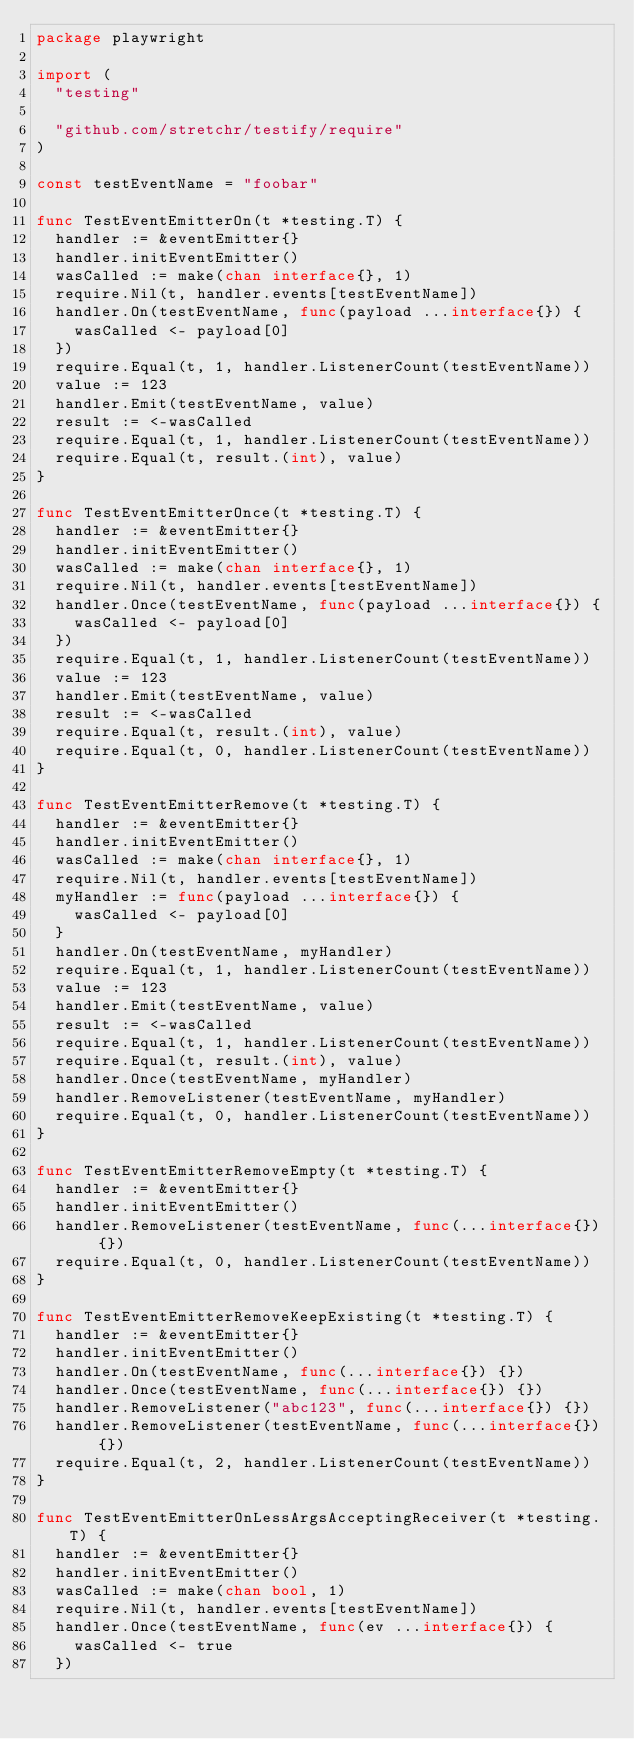<code> <loc_0><loc_0><loc_500><loc_500><_Go_>package playwright

import (
	"testing"

	"github.com/stretchr/testify/require"
)

const testEventName = "foobar"

func TestEventEmitterOn(t *testing.T) {
	handler := &eventEmitter{}
	handler.initEventEmitter()
	wasCalled := make(chan interface{}, 1)
	require.Nil(t, handler.events[testEventName])
	handler.On(testEventName, func(payload ...interface{}) {
		wasCalled <- payload[0]
	})
	require.Equal(t, 1, handler.ListenerCount(testEventName))
	value := 123
	handler.Emit(testEventName, value)
	result := <-wasCalled
	require.Equal(t, 1, handler.ListenerCount(testEventName))
	require.Equal(t, result.(int), value)
}

func TestEventEmitterOnce(t *testing.T) {
	handler := &eventEmitter{}
	handler.initEventEmitter()
	wasCalled := make(chan interface{}, 1)
	require.Nil(t, handler.events[testEventName])
	handler.Once(testEventName, func(payload ...interface{}) {
		wasCalled <- payload[0]
	})
	require.Equal(t, 1, handler.ListenerCount(testEventName))
	value := 123
	handler.Emit(testEventName, value)
	result := <-wasCalled
	require.Equal(t, result.(int), value)
	require.Equal(t, 0, handler.ListenerCount(testEventName))
}

func TestEventEmitterRemove(t *testing.T) {
	handler := &eventEmitter{}
	handler.initEventEmitter()
	wasCalled := make(chan interface{}, 1)
	require.Nil(t, handler.events[testEventName])
	myHandler := func(payload ...interface{}) {
		wasCalled <- payload[0]
	}
	handler.On(testEventName, myHandler)
	require.Equal(t, 1, handler.ListenerCount(testEventName))
	value := 123
	handler.Emit(testEventName, value)
	result := <-wasCalled
	require.Equal(t, 1, handler.ListenerCount(testEventName))
	require.Equal(t, result.(int), value)
	handler.Once(testEventName, myHandler)
	handler.RemoveListener(testEventName, myHandler)
	require.Equal(t, 0, handler.ListenerCount(testEventName))
}

func TestEventEmitterRemoveEmpty(t *testing.T) {
	handler := &eventEmitter{}
	handler.initEventEmitter()
	handler.RemoveListener(testEventName, func(...interface{}) {})
	require.Equal(t, 0, handler.ListenerCount(testEventName))
}

func TestEventEmitterRemoveKeepExisting(t *testing.T) {
	handler := &eventEmitter{}
	handler.initEventEmitter()
	handler.On(testEventName, func(...interface{}) {})
	handler.Once(testEventName, func(...interface{}) {})
	handler.RemoveListener("abc123", func(...interface{}) {})
	handler.RemoveListener(testEventName, func(...interface{}) {})
	require.Equal(t, 2, handler.ListenerCount(testEventName))
}

func TestEventEmitterOnLessArgsAcceptingReceiver(t *testing.T) {
	handler := &eventEmitter{}
	handler.initEventEmitter()
	wasCalled := make(chan bool, 1)
	require.Nil(t, handler.events[testEventName])
	handler.Once(testEventName, func(ev ...interface{}) {
		wasCalled <- true
	})</code> 